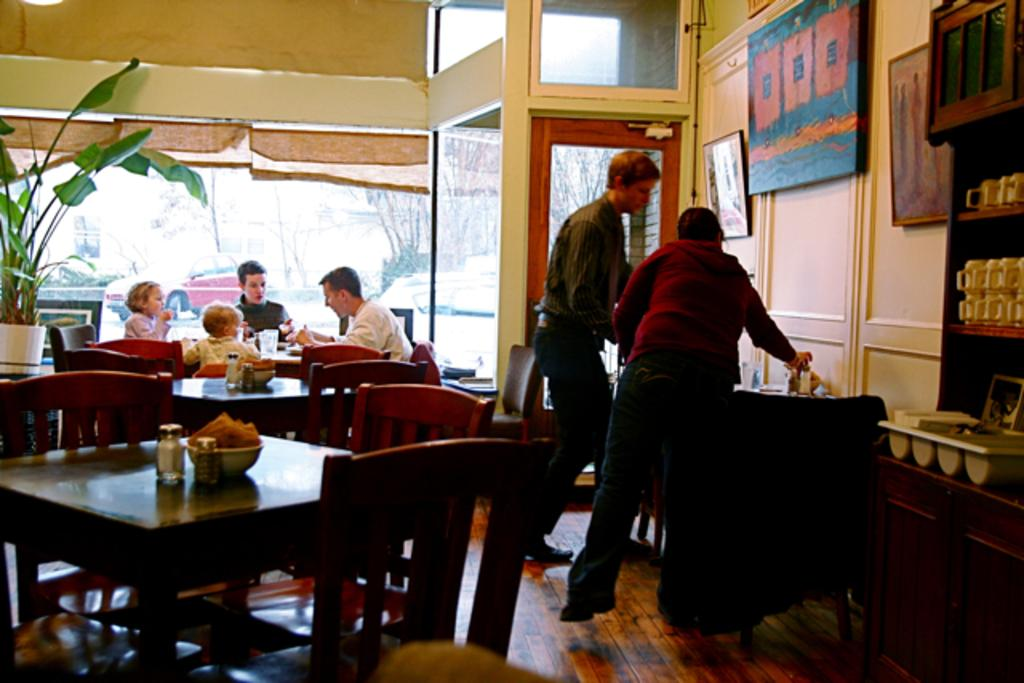What type of furniture can be seen in the room? There are chairs and at least one table in the room. Can you describe any decorative items in the room? There is a photo frame on a wall. What can be found on the shelves in the room? The shelves have coffee cups. What type of war is depicted in the photo frame on the wall? There is no war depicted in the photo frame on the wall; it is a decorative item and not a historical or political representation. 